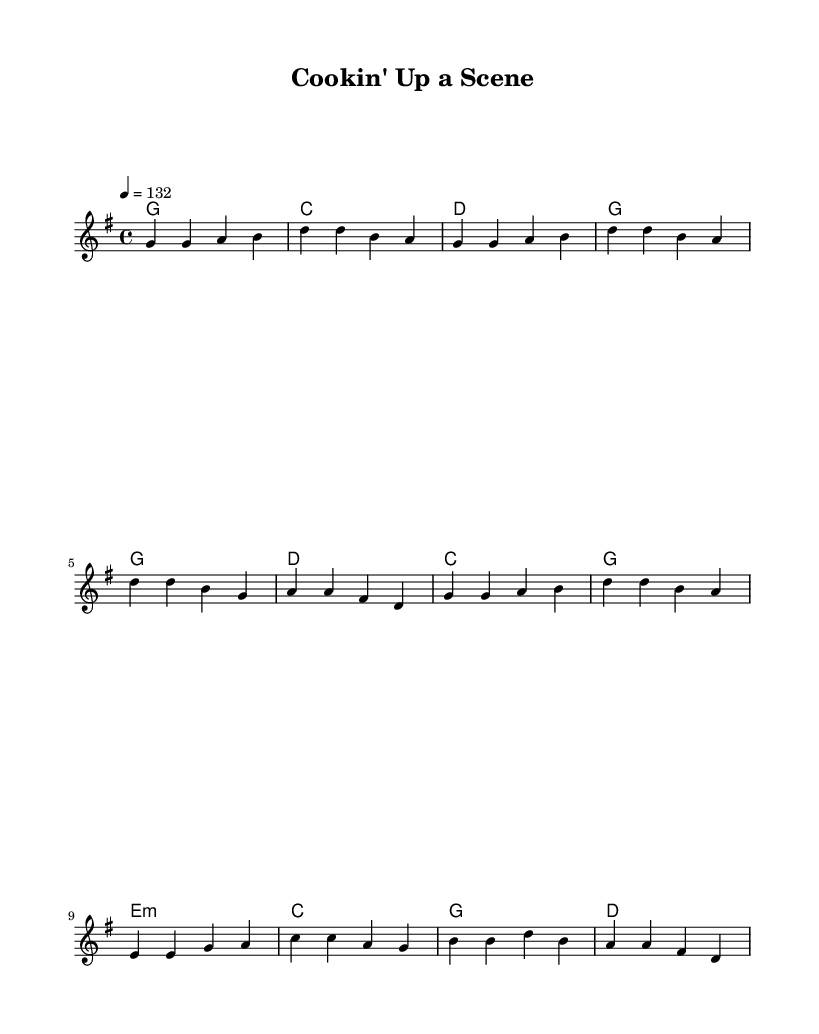What is the key signature of this music? The key signature is G major, which has one sharp (F#). This can be identified at the beginning of the sheet music, where the key signature is indicated before the time signature.
Answer: G major What is the time signature of this music? The time signature is 4/4, which is indicated at the beginning of the music. This means there are four beats in a measure and the quarter note gets one beat.
Answer: 4/4 What is the tempo marking for this piece? The tempo marking is 132, which indicates the speed of the music. It is found within the tempo text at the beginning of the score.
Answer: 132 How many bars are in the verse section? The verse section consists of four bars, as can be seen in the melody section where the verse is laid out. Each line of the melody corresponds to a measure or bar.
Answer: 4 What chord follows the D major chord in the chorus? The D major chord is followed by a C major chord in the chorus, indicated in the harmonies section where the chords are assigned to each measure of the melody.
Answer: C What is the lyric theme conveyed in the chorus? The chorus conveys a theme of improvisation and creativity in cooking, as reflected in the lyrics "We're cookin' up a scene, stirrin' the pot." This indicates the playful and collaborative spirit of both theater and cooking.
Answer: Improvisation What type of musical form does this piece mainly follow? This piece mainly follows a verse-chorus form, as evident by the separate sections designated for the verse and the chorus in both the melody and lyrics, creating a structure common in country rock music.
Answer: Verse-chorus 